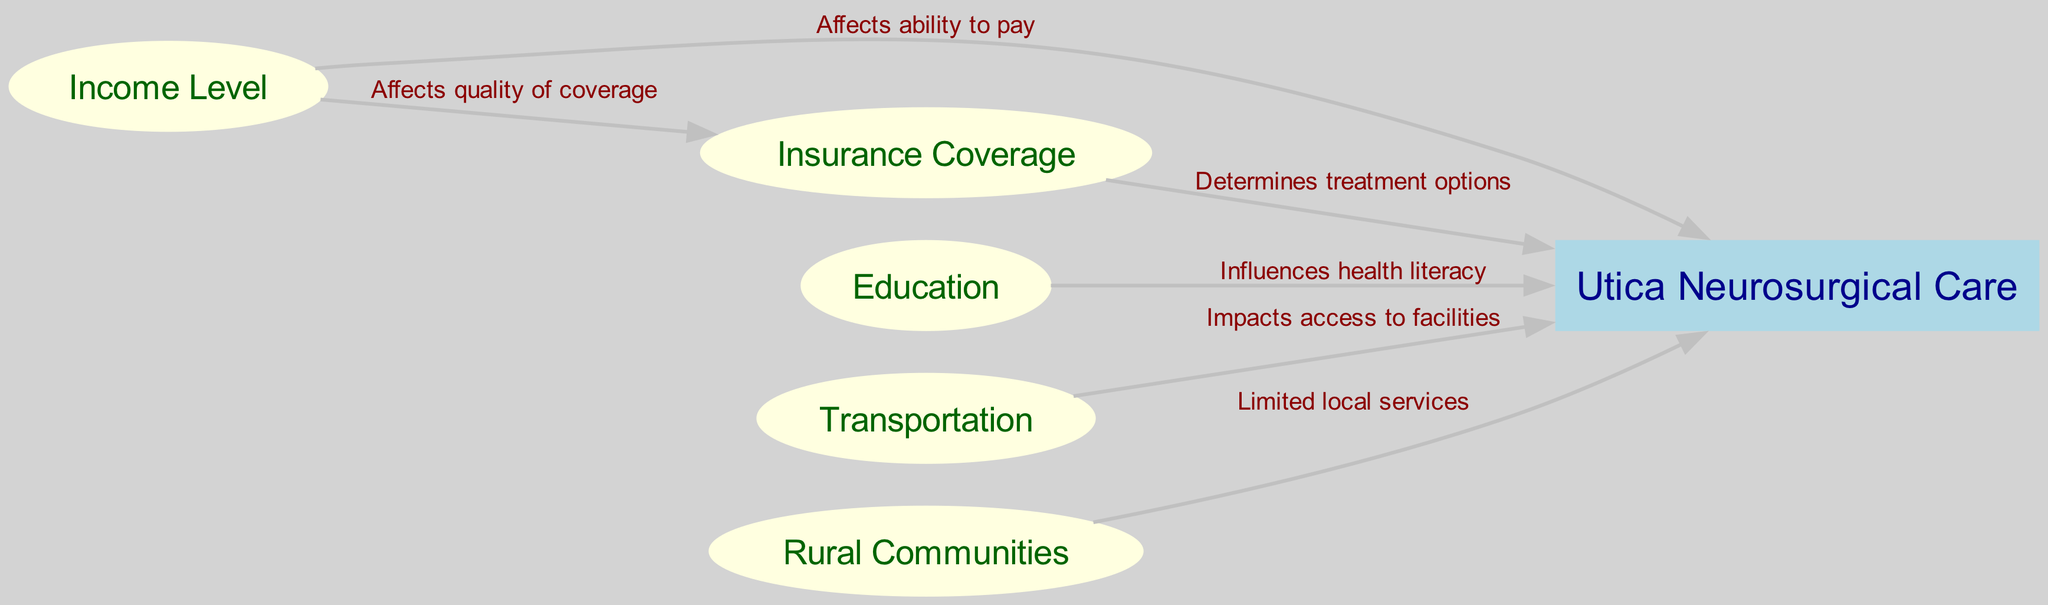What is the main node in the diagram? The main node, representing the central focus of the diagram, is "Utica Neurosurgical Care." This is clearly labeled in a rectangle shape, indicating its importance in relation to the socioeconomic factors illustrated by the other nodes.
Answer: Utica Neurosurgical Care How many nodes are present in the diagram? To find the number of nodes, we count each unique node in the 'nodes' section of the data. There are a total of six nodes identified, including the central and the socioeconomic factors.
Answer: 6 Which socioeconomic factor is linked to "quality of coverage"? The factor linked to "quality of coverage" is "Income Level." This relationship is represented by an edge that specifically states how income influences the quality of insurance coverage available.
Answer: Income Level What is the relationship between "Education" and "Utica Neurosurgical Care"? The relationship depicted is that "Education" influences "health literacy," which is crucial for patients to understand their medical options. This connection indicates how education impacts patients' ability to navigate their healthcare needs.
Answer: Influences health literacy How does "Transportation" impact access to neurosurgical care? "Transportation" impacts access to facilities, as portrayed through the edge in the diagram. This indicates that the ability to travel to treatment centers directly affects how readily individuals can receive neurosurgical care.
Answer: Impacts access to facilities Which socioeconomic factor has a direct effect on the ability to pay for care? The socioeconomic factor that affects the ability to pay for care is "Income Level." The directed edge illustrates that a person's income level directly influences their financial capacity to afford neurosurgical services.
Answer: Income Level How many edges are present in the diagram? By counting the connections listed in the 'edges' section, we find a total of five edges that represent the relationships between the various socioeconomic factors and the main node.
Answer: 5 What does the edge labeled "Limited local services" imply? The edge labeled "Limited local services" shows how "Rural Communities" face challenges due to fewer healthcare facilities being available, which restricts access to needed neurosurgical care in those areas.
Answer: Limited local services What is the role of "Insurance Coverage" in relation to treatment options? "Insurance Coverage" determines treatment options available to patients, indicating that the type and extent of coverage affects what medical interventions can be pursued in neurosurgery.
Answer: Determines treatment options 